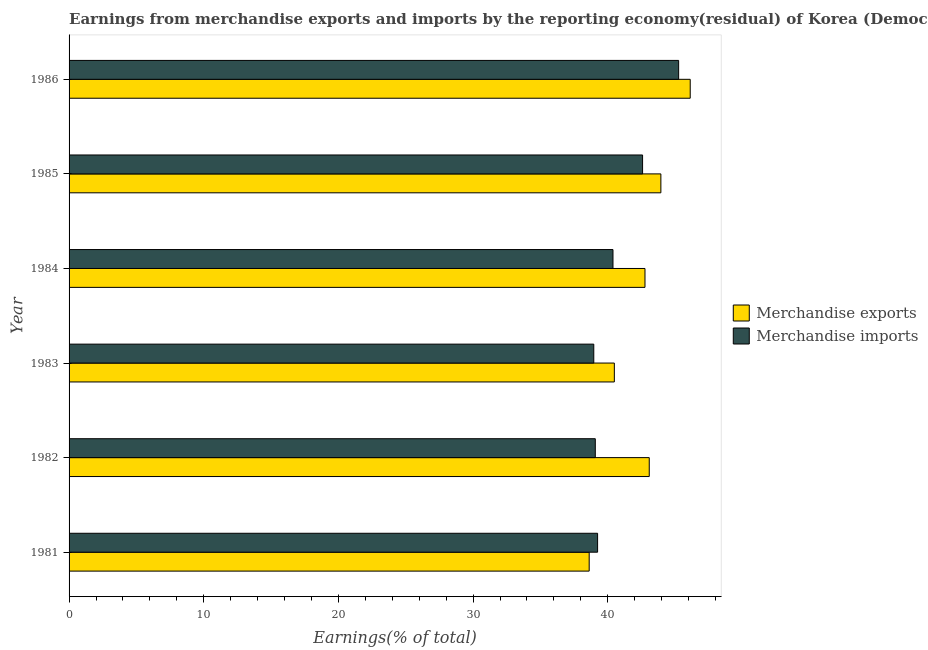How many different coloured bars are there?
Offer a terse response. 2. How many groups of bars are there?
Offer a terse response. 6. Are the number of bars on each tick of the Y-axis equal?
Make the answer very short. Yes. How many bars are there on the 3rd tick from the top?
Provide a short and direct response. 2. In how many cases, is the number of bars for a given year not equal to the number of legend labels?
Ensure brevity in your answer.  0. What is the earnings from merchandise imports in 1981?
Keep it short and to the point. 39.25. Across all years, what is the maximum earnings from merchandise imports?
Keep it short and to the point. 45.27. Across all years, what is the minimum earnings from merchandise imports?
Your response must be concise. 38.96. What is the total earnings from merchandise imports in the graph?
Give a very brief answer. 245.53. What is the difference between the earnings from merchandise exports in 1985 and that in 1986?
Your response must be concise. -2.18. What is the difference between the earnings from merchandise exports in 1984 and the earnings from merchandise imports in 1983?
Keep it short and to the point. 3.8. What is the average earnings from merchandise exports per year?
Offer a terse response. 42.51. In the year 1986, what is the difference between the earnings from merchandise exports and earnings from merchandise imports?
Your answer should be very brief. 0.86. In how many years, is the earnings from merchandise exports greater than 8 %?
Ensure brevity in your answer.  6. What is the ratio of the earnings from merchandise exports in 1983 to that in 1984?
Provide a short and direct response. 0.95. What is the difference between the highest and the second highest earnings from merchandise imports?
Provide a short and direct response. 2.68. In how many years, is the earnings from merchandise exports greater than the average earnings from merchandise exports taken over all years?
Your response must be concise. 4. What does the 2nd bar from the top in 1986 represents?
Make the answer very short. Merchandise exports. How many bars are there?
Provide a short and direct response. 12. Are all the bars in the graph horizontal?
Give a very brief answer. Yes. How many years are there in the graph?
Your answer should be very brief. 6. Are the values on the major ticks of X-axis written in scientific E-notation?
Keep it short and to the point. No. Does the graph contain any zero values?
Your response must be concise. No. Where does the legend appear in the graph?
Keep it short and to the point. Center right. How many legend labels are there?
Make the answer very short. 2. What is the title of the graph?
Give a very brief answer. Earnings from merchandise exports and imports by the reporting economy(residual) of Korea (Democratic). Does "Not attending school" appear as one of the legend labels in the graph?
Your response must be concise. No. What is the label or title of the X-axis?
Your answer should be compact. Earnings(% of total). What is the label or title of the Y-axis?
Offer a very short reply. Year. What is the Earnings(% of total) of Merchandise exports in 1981?
Offer a very short reply. 38.62. What is the Earnings(% of total) in Merchandise imports in 1981?
Your answer should be very brief. 39.25. What is the Earnings(% of total) of Merchandise exports in 1982?
Give a very brief answer. 43.08. What is the Earnings(% of total) of Merchandise imports in 1982?
Keep it short and to the point. 39.08. What is the Earnings(% of total) in Merchandise exports in 1983?
Provide a short and direct response. 40.49. What is the Earnings(% of total) of Merchandise imports in 1983?
Keep it short and to the point. 38.96. What is the Earnings(% of total) of Merchandise exports in 1984?
Keep it short and to the point. 42.77. What is the Earnings(% of total) in Merchandise imports in 1984?
Your answer should be very brief. 40.39. What is the Earnings(% of total) in Merchandise exports in 1985?
Make the answer very short. 43.95. What is the Earnings(% of total) in Merchandise imports in 1985?
Provide a short and direct response. 42.59. What is the Earnings(% of total) in Merchandise exports in 1986?
Keep it short and to the point. 46.12. What is the Earnings(% of total) of Merchandise imports in 1986?
Your answer should be compact. 45.27. Across all years, what is the maximum Earnings(% of total) in Merchandise exports?
Offer a very short reply. 46.12. Across all years, what is the maximum Earnings(% of total) of Merchandise imports?
Your answer should be very brief. 45.27. Across all years, what is the minimum Earnings(% of total) in Merchandise exports?
Offer a very short reply. 38.62. Across all years, what is the minimum Earnings(% of total) of Merchandise imports?
Provide a short and direct response. 38.96. What is the total Earnings(% of total) of Merchandise exports in the graph?
Ensure brevity in your answer.  255.03. What is the total Earnings(% of total) in Merchandise imports in the graph?
Make the answer very short. 245.53. What is the difference between the Earnings(% of total) in Merchandise exports in 1981 and that in 1982?
Keep it short and to the point. -4.46. What is the difference between the Earnings(% of total) in Merchandise imports in 1981 and that in 1982?
Provide a succinct answer. 0.17. What is the difference between the Earnings(% of total) of Merchandise exports in 1981 and that in 1983?
Ensure brevity in your answer.  -1.87. What is the difference between the Earnings(% of total) of Merchandise imports in 1981 and that in 1983?
Your response must be concise. 0.28. What is the difference between the Earnings(% of total) in Merchandise exports in 1981 and that in 1984?
Provide a succinct answer. -4.14. What is the difference between the Earnings(% of total) in Merchandise imports in 1981 and that in 1984?
Provide a succinct answer. -1.14. What is the difference between the Earnings(% of total) of Merchandise exports in 1981 and that in 1985?
Keep it short and to the point. -5.32. What is the difference between the Earnings(% of total) of Merchandise imports in 1981 and that in 1985?
Keep it short and to the point. -3.34. What is the difference between the Earnings(% of total) of Merchandise exports in 1981 and that in 1986?
Ensure brevity in your answer.  -7.5. What is the difference between the Earnings(% of total) in Merchandise imports in 1981 and that in 1986?
Give a very brief answer. -6.02. What is the difference between the Earnings(% of total) of Merchandise exports in 1982 and that in 1983?
Ensure brevity in your answer.  2.59. What is the difference between the Earnings(% of total) in Merchandise imports in 1982 and that in 1983?
Your answer should be very brief. 0.11. What is the difference between the Earnings(% of total) of Merchandise exports in 1982 and that in 1984?
Your answer should be very brief. 0.32. What is the difference between the Earnings(% of total) of Merchandise imports in 1982 and that in 1984?
Your answer should be very brief. -1.31. What is the difference between the Earnings(% of total) of Merchandise exports in 1982 and that in 1985?
Your answer should be very brief. -0.86. What is the difference between the Earnings(% of total) of Merchandise imports in 1982 and that in 1985?
Make the answer very short. -3.51. What is the difference between the Earnings(% of total) in Merchandise exports in 1982 and that in 1986?
Give a very brief answer. -3.04. What is the difference between the Earnings(% of total) in Merchandise imports in 1982 and that in 1986?
Keep it short and to the point. -6.19. What is the difference between the Earnings(% of total) of Merchandise exports in 1983 and that in 1984?
Ensure brevity in your answer.  -2.28. What is the difference between the Earnings(% of total) of Merchandise imports in 1983 and that in 1984?
Your response must be concise. -1.43. What is the difference between the Earnings(% of total) of Merchandise exports in 1983 and that in 1985?
Offer a terse response. -3.46. What is the difference between the Earnings(% of total) of Merchandise imports in 1983 and that in 1985?
Offer a terse response. -3.62. What is the difference between the Earnings(% of total) of Merchandise exports in 1983 and that in 1986?
Your answer should be very brief. -5.63. What is the difference between the Earnings(% of total) of Merchandise imports in 1983 and that in 1986?
Keep it short and to the point. -6.3. What is the difference between the Earnings(% of total) of Merchandise exports in 1984 and that in 1985?
Offer a terse response. -1.18. What is the difference between the Earnings(% of total) of Merchandise imports in 1984 and that in 1985?
Your answer should be compact. -2.2. What is the difference between the Earnings(% of total) of Merchandise exports in 1984 and that in 1986?
Keep it short and to the point. -3.36. What is the difference between the Earnings(% of total) of Merchandise imports in 1984 and that in 1986?
Provide a short and direct response. -4.88. What is the difference between the Earnings(% of total) in Merchandise exports in 1985 and that in 1986?
Your answer should be very brief. -2.18. What is the difference between the Earnings(% of total) in Merchandise imports in 1985 and that in 1986?
Make the answer very short. -2.68. What is the difference between the Earnings(% of total) of Merchandise exports in 1981 and the Earnings(% of total) of Merchandise imports in 1982?
Your answer should be very brief. -0.45. What is the difference between the Earnings(% of total) in Merchandise exports in 1981 and the Earnings(% of total) in Merchandise imports in 1983?
Provide a succinct answer. -0.34. What is the difference between the Earnings(% of total) in Merchandise exports in 1981 and the Earnings(% of total) in Merchandise imports in 1984?
Offer a very short reply. -1.77. What is the difference between the Earnings(% of total) in Merchandise exports in 1981 and the Earnings(% of total) in Merchandise imports in 1985?
Your answer should be very brief. -3.96. What is the difference between the Earnings(% of total) of Merchandise exports in 1981 and the Earnings(% of total) of Merchandise imports in 1986?
Your response must be concise. -6.64. What is the difference between the Earnings(% of total) in Merchandise exports in 1982 and the Earnings(% of total) in Merchandise imports in 1983?
Your response must be concise. 4.12. What is the difference between the Earnings(% of total) of Merchandise exports in 1982 and the Earnings(% of total) of Merchandise imports in 1984?
Give a very brief answer. 2.69. What is the difference between the Earnings(% of total) of Merchandise exports in 1982 and the Earnings(% of total) of Merchandise imports in 1985?
Offer a very short reply. 0.5. What is the difference between the Earnings(% of total) in Merchandise exports in 1982 and the Earnings(% of total) in Merchandise imports in 1986?
Give a very brief answer. -2.18. What is the difference between the Earnings(% of total) of Merchandise exports in 1983 and the Earnings(% of total) of Merchandise imports in 1984?
Offer a very short reply. 0.1. What is the difference between the Earnings(% of total) in Merchandise exports in 1983 and the Earnings(% of total) in Merchandise imports in 1985?
Your answer should be very brief. -2.1. What is the difference between the Earnings(% of total) in Merchandise exports in 1983 and the Earnings(% of total) in Merchandise imports in 1986?
Your answer should be very brief. -4.78. What is the difference between the Earnings(% of total) in Merchandise exports in 1984 and the Earnings(% of total) in Merchandise imports in 1985?
Offer a very short reply. 0.18. What is the difference between the Earnings(% of total) in Merchandise exports in 1984 and the Earnings(% of total) in Merchandise imports in 1986?
Provide a short and direct response. -2.5. What is the difference between the Earnings(% of total) of Merchandise exports in 1985 and the Earnings(% of total) of Merchandise imports in 1986?
Make the answer very short. -1.32. What is the average Earnings(% of total) in Merchandise exports per year?
Provide a succinct answer. 42.51. What is the average Earnings(% of total) in Merchandise imports per year?
Make the answer very short. 40.92. In the year 1981, what is the difference between the Earnings(% of total) of Merchandise exports and Earnings(% of total) of Merchandise imports?
Give a very brief answer. -0.62. In the year 1982, what is the difference between the Earnings(% of total) of Merchandise exports and Earnings(% of total) of Merchandise imports?
Offer a very short reply. 4.01. In the year 1983, what is the difference between the Earnings(% of total) of Merchandise exports and Earnings(% of total) of Merchandise imports?
Your answer should be compact. 1.53. In the year 1984, what is the difference between the Earnings(% of total) in Merchandise exports and Earnings(% of total) in Merchandise imports?
Your answer should be very brief. 2.38. In the year 1985, what is the difference between the Earnings(% of total) in Merchandise exports and Earnings(% of total) in Merchandise imports?
Ensure brevity in your answer.  1.36. In the year 1986, what is the difference between the Earnings(% of total) of Merchandise exports and Earnings(% of total) of Merchandise imports?
Offer a very short reply. 0.86. What is the ratio of the Earnings(% of total) of Merchandise exports in 1981 to that in 1982?
Your answer should be compact. 0.9. What is the ratio of the Earnings(% of total) of Merchandise imports in 1981 to that in 1982?
Make the answer very short. 1. What is the ratio of the Earnings(% of total) of Merchandise exports in 1981 to that in 1983?
Your answer should be very brief. 0.95. What is the ratio of the Earnings(% of total) in Merchandise imports in 1981 to that in 1983?
Your answer should be compact. 1.01. What is the ratio of the Earnings(% of total) of Merchandise exports in 1981 to that in 1984?
Your response must be concise. 0.9. What is the ratio of the Earnings(% of total) of Merchandise imports in 1981 to that in 1984?
Keep it short and to the point. 0.97. What is the ratio of the Earnings(% of total) in Merchandise exports in 1981 to that in 1985?
Provide a short and direct response. 0.88. What is the ratio of the Earnings(% of total) in Merchandise imports in 1981 to that in 1985?
Your answer should be very brief. 0.92. What is the ratio of the Earnings(% of total) of Merchandise exports in 1981 to that in 1986?
Your response must be concise. 0.84. What is the ratio of the Earnings(% of total) of Merchandise imports in 1981 to that in 1986?
Give a very brief answer. 0.87. What is the ratio of the Earnings(% of total) of Merchandise exports in 1982 to that in 1983?
Provide a succinct answer. 1.06. What is the ratio of the Earnings(% of total) in Merchandise exports in 1982 to that in 1984?
Ensure brevity in your answer.  1.01. What is the ratio of the Earnings(% of total) in Merchandise imports in 1982 to that in 1984?
Give a very brief answer. 0.97. What is the ratio of the Earnings(% of total) in Merchandise exports in 1982 to that in 1985?
Your response must be concise. 0.98. What is the ratio of the Earnings(% of total) of Merchandise imports in 1982 to that in 1985?
Offer a very short reply. 0.92. What is the ratio of the Earnings(% of total) of Merchandise exports in 1982 to that in 1986?
Offer a terse response. 0.93. What is the ratio of the Earnings(% of total) in Merchandise imports in 1982 to that in 1986?
Give a very brief answer. 0.86. What is the ratio of the Earnings(% of total) in Merchandise exports in 1983 to that in 1984?
Give a very brief answer. 0.95. What is the ratio of the Earnings(% of total) in Merchandise imports in 1983 to that in 1984?
Give a very brief answer. 0.96. What is the ratio of the Earnings(% of total) of Merchandise exports in 1983 to that in 1985?
Give a very brief answer. 0.92. What is the ratio of the Earnings(% of total) of Merchandise imports in 1983 to that in 1985?
Keep it short and to the point. 0.91. What is the ratio of the Earnings(% of total) of Merchandise exports in 1983 to that in 1986?
Your answer should be compact. 0.88. What is the ratio of the Earnings(% of total) in Merchandise imports in 1983 to that in 1986?
Your response must be concise. 0.86. What is the ratio of the Earnings(% of total) in Merchandise exports in 1984 to that in 1985?
Give a very brief answer. 0.97. What is the ratio of the Earnings(% of total) in Merchandise imports in 1984 to that in 1985?
Your answer should be very brief. 0.95. What is the ratio of the Earnings(% of total) in Merchandise exports in 1984 to that in 1986?
Your answer should be very brief. 0.93. What is the ratio of the Earnings(% of total) of Merchandise imports in 1984 to that in 1986?
Give a very brief answer. 0.89. What is the ratio of the Earnings(% of total) of Merchandise exports in 1985 to that in 1986?
Your answer should be compact. 0.95. What is the ratio of the Earnings(% of total) of Merchandise imports in 1985 to that in 1986?
Provide a short and direct response. 0.94. What is the difference between the highest and the second highest Earnings(% of total) in Merchandise exports?
Provide a succinct answer. 2.18. What is the difference between the highest and the second highest Earnings(% of total) in Merchandise imports?
Offer a very short reply. 2.68. What is the difference between the highest and the lowest Earnings(% of total) of Merchandise exports?
Offer a very short reply. 7.5. What is the difference between the highest and the lowest Earnings(% of total) of Merchandise imports?
Provide a short and direct response. 6.3. 